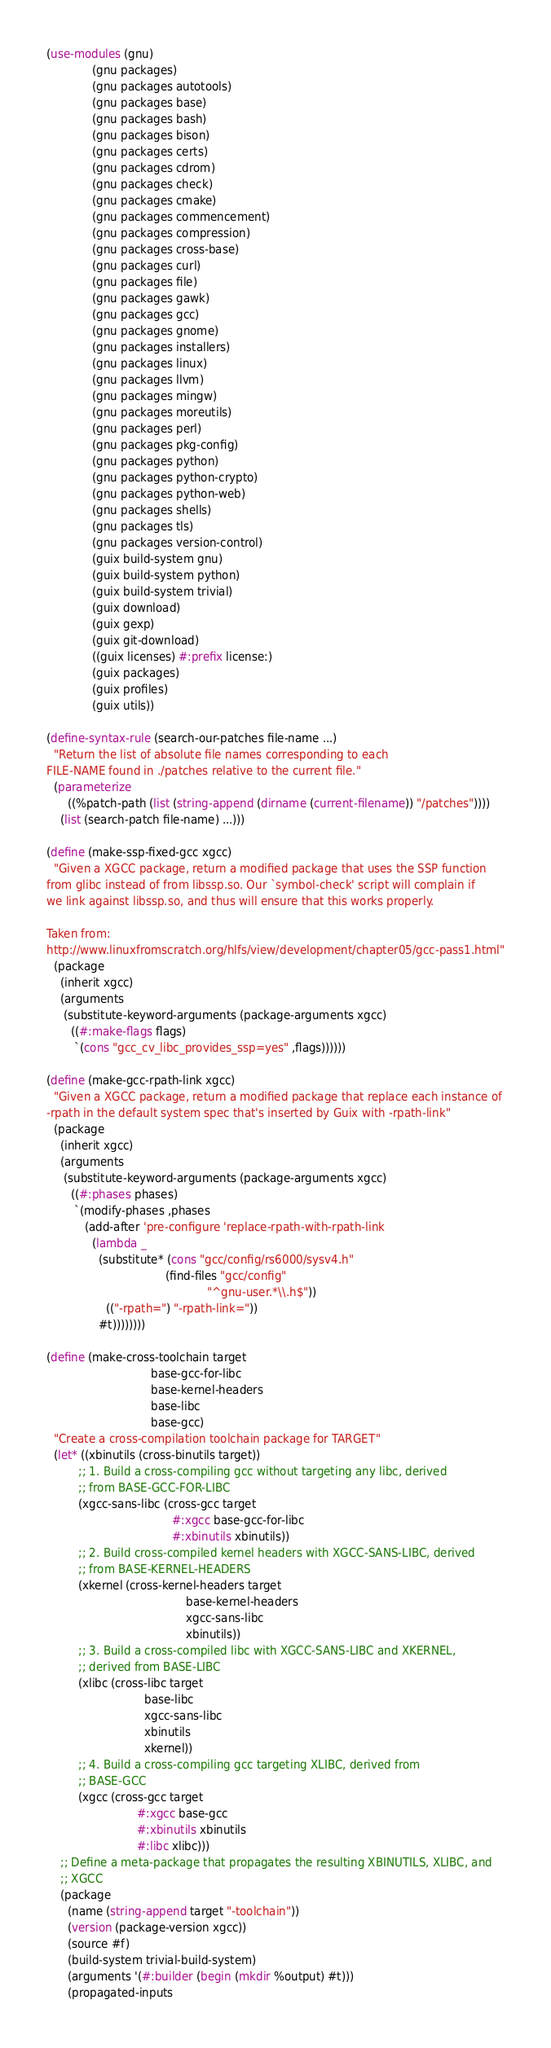Convert code to text. <code><loc_0><loc_0><loc_500><loc_500><_Scheme_>(use-modules (gnu)
             (gnu packages)
             (gnu packages autotools)
             (gnu packages base)
             (gnu packages bash)
             (gnu packages bison)
             (gnu packages certs)
             (gnu packages cdrom)
             (gnu packages check)
             (gnu packages cmake)
             (gnu packages commencement)
             (gnu packages compression)
             (gnu packages cross-base)
             (gnu packages curl)
             (gnu packages file)
             (gnu packages gawk)
             (gnu packages gcc)
             (gnu packages gnome)
             (gnu packages installers)
             (gnu packages linux)
             (gnu packages llvm)
             (gnu packages mingw)
             (gnu packages moreutils)
             (gnu packages perl)
             (gnu packages pkg-config)
             (gnu packages python)
             (gnu packages python-crypto)
             (gnu packages python-web)
             (gnu packages shells)
             (gnu packages tls)
             (gnu packages version-control)
             (guix build-system gnu)
             (guix build-system python)
             (guix build-system trivial)
             (guix download)
             (guix gexp)
             (guix git-download)
             ((guix licenses) #:prefix license:)
             (guix packages)
             (guix profiles)
             (guix utils))

(define-syntax-rule (search-our-patches file-name ...)
  "Return the list of absolute file names corresponding to each
FILE-NAME found in ./patches relative to the current file."
  (parameterize
      ((%patch-path (list (string-append (dirname (current-filename)) "/patches"))))
    (list (search-patch file-name) ...)))

(define (make-ssp-fixed-gcc xgcc)
  "Given a XGCC package, return a modified package that uses the SSP function
from glibc instead of from libssp.so. Our `symbol-check' script will complain if
we link against libssp.so, and thus will ensure that this works properly.

Taken from:
http://www.linuxfromscratch.org/hlfs/view/development/chapter05/gcc-pass1.html"
  (package
    (inherit xgcc)
    (arguments
     (substitute-keyword-arguments (package-arguments xgcc)
       ((#:make-flags flags)
        `(cons "gcc_cv_libc_provides_ssp=yes" ,flags))))))

(define (make-gcc-rpath-link xgcc)
  "Given a XGCC package, return a modified package that replace each instance of
-rpath in the default system spec that's inserted by Guix with -rpath-link"
  (package
    (inherit xgcc)
    (arguments
     (substitute-keyword-arguments (package-arguments xgcc)
       ((#:phases phases)
        `(modify-phases ,phases
           (add-after 'pre-configure 'replace-rpath-with-rpath-link
             (lambda _
               (substitute* (cons "gcc/config/rs6000/sysv4.h"
                                  (find-files "gcc/config"
                                              "^gnu-user.*\\.h$"))
                 (("-rpath=") "-rpath-link="))
               #t))))))))

(define (make-cross-toolchain target
                              base-gcc-for-libc
                              base-kernel-headers
                              base-libc
                              base-gcc)
  "Create a cross-compilation toolchain package for TARGET"
  (let* ((xbinutils (cross-binutils target))
         ;; 1. Build a cross-compiling gcc without targeting any libc, derived
         ;; from BASE-GCC-FOR-LIBC
         (xgcc-sans-libc (cross-gcc target
                                    #:xgcc base-gcc-for-libc
                                    #:xbinutils xbinutils))
         ;; 2. Build cross-compiled kernel headers with XGCC-SANS-LIBC, derived
         ;; from BASE-KERNEL-HEADERS
         (xkernel (cross-kernel-headers target
                                        base-kernel-headers
                                        xgcc-sans-libc
                                        xbinutils))
         ;; 3. Build a cross-compiled libc with XGCC-SANS-LIBC and XKERNEL,
         ;; derived from BASE-LIBC
         (xlibc (cross-libc target
                            base-libc
                            xgcc-sans-libc
                            xbinutils
                            xkernel))
         ;; 4. Build a cross-compiling gcc targeting XLIBC, derived from
         ;; BASE-GCC
         (xgcc (cross-gcc target
                          #:xgcc base-gcc
                          #:xbinutils xbinutils
                          #:libc xlibc)))
    ;; Define a meta-package that propagates the resulting XBINUTILS, XLIBC, and
    ;; XGCC
    (package
      (name (string-append target "-toolchain"))
      (version (package-version xgcc))
      (source #f)
      (build-system trivial-build-system)
      (arguments '(#:builder (begin (mkdir %output) #t)))
      (propagated-inputs</code> 